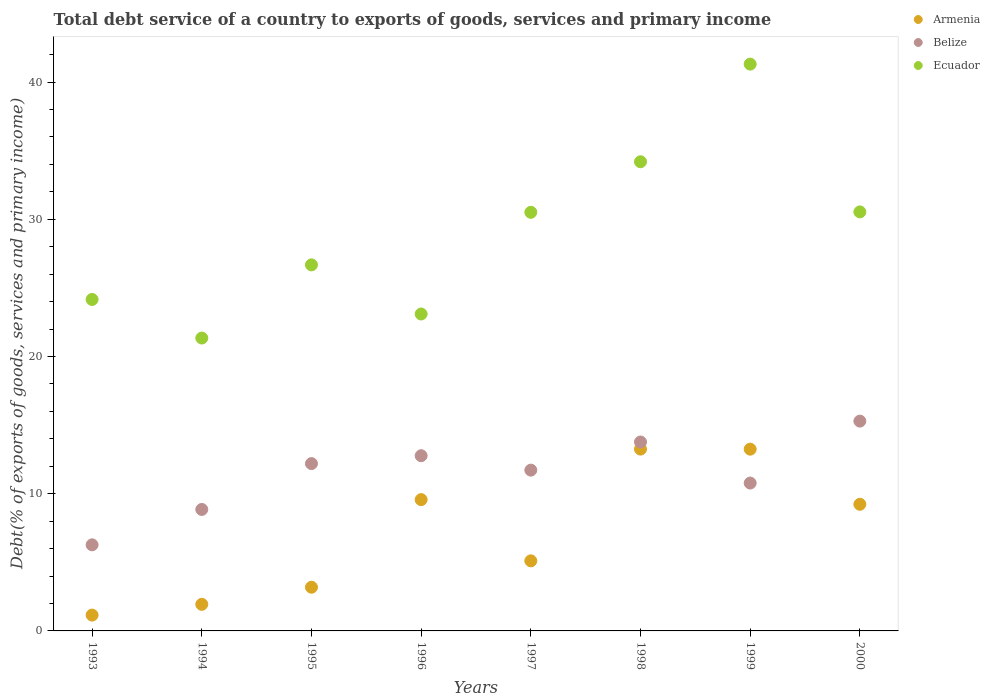How many different coloured dotlines are there?
Give a very brief answer. 3. Is the number of dotlines equal to the number of legend labels?
Provide a succinct answer. Yes. What is the total debt service in Ecuador in 2000?
Give a very brief answer. 30.54. Across all years, what is the maximum total debt service in Ecuador?
Offer a very short reply. 41.31. Across all years, what is the minimum total debt service in Armenia?
Your answer should be compact. 1.15. In which year was the total debt service in Ecuador maximum?
Your answer should be very brief. 1999. What is the total total debt service in Belize in the graph?
Give a very brief answer. 91.65. What is the difference between the total debt service in Ecuador in 1997 and that in 2000?
Make the answer very short. -0.03. What is the difference between the total debt service in Armenia in 1994 and the total debt service in Ecuador in 1996?
Offer a very short reply. -21.16. What is the average total debt service in Ecuador per year?
Make the answer very short. 28.98. In the year 2000, what is the difference between the total debt service in Ecuador and total debt service in Belize?
Ensure brevity in your answer.  15.25. In how many years, is the total debt service in Armenia greater than 4 %?
Give a very brief answer. 5. What is the ratio of the total debt service in Armenia in 1996 to that in 1998?
Your answer should be very brief. 0.72. Is the total debt service in Belize in 1995 less than that in 1997?
Keep it short and to the point. No. What is the difference between the highest and the second highest total debt service in Ecuador?
Offer a very short reply. 7.12. What is the difference between the highest and the lowest total debt service in Belize?
Your response must be concise. 9.02. In how many years, is the total debt service in Ecuador greater than the average total debt service in Ecuador taken over all years?
Make the answer very short. 4. Is the sum of the total debt service in Ecuador in 1999 and 2000 greater than the maximum total debt service in Armenia across all years?
Provide a short and direct response. Yes. Is it the case that in every year, the sum of the total debt service in Armenia and total debt service in Ecuador  is greater than the total debt service in Belize?
Your response must be concise. Yes. Is the total debt service in Armenia strictly greater than the total debt service in Ecuador over the years?
Make the answer very short. No. Is the total debt service in Armenia strictly less than the total debt service in Ecuador over the years?
Your answer should be compact. Yes. How many years are there in the graph?
Offer a terse response. 8. Are the values on the major ticks of Y-axis written in scientific E-notation?
Provide a succinct answer. No. Does the graph contain grids?
Offer a terse response. No. Where does the legend appear in the graph?
Keep it short and to the point. Top right. How many legend labels are there?
Offer a terse response. 3. How are the legend labels stacked?
Provide a succinct answer. Vertical. What is the title of the graph?
Provide a succinct answer. Total debt service of a country to exports of goods, services and primary income. What is the label or title of the Y-axis?
Your answer should be very brief. Debt(% of exports of goods, services and primary income). What is the Debt(% of exports of goods, services and primary income) in Armenia in 1993?
Provide a succinct answer. 1.15. What is the Debt(% of exports of goods, services and primary income) in Belize in 1993?
Your answer should be very brief. 6.28. What is the Debt(% of exports of goods, services and primary income) in Ecuador in 1993?
Keep it short and to the point. 24.16. What is the Debt(% of exports of goods, services and primary income) of Armenia in 1994?
Make the answer very short. 1.94. What is the Debt(% of exports of goods, services and primary income) in Belize in 1994?
Your answer should be very brief. 8.85. What is the Debt(% of exports of goods, services and primary income) in Ecuador in 1994?
Keep it short and to the point. 21.35. What is the Debt(% of exports of goods, services and primary income) of Armenia in 1995?
Keep it short and to the point. 3.18. What is the Debt(% of exports of goods, services and primary income) of Belize in 1995?
Make the answer very short. 12.19. What is the Debt(% of exports of goods, services and primary income) of Ecuador in 1995?
Your answer should be compact. 26.68. What is the Debt(% of exports of goods, services and primary income) in Armenia in 1996?
Your answer should be very brief. 9.57. What is the Debt(% of exports of goods, services and primary income) in Belize in 1996?
Your answer should be very brief. 12.77. What is the Debt(% of exports of goods, services and primary income) in Ecuador in 1996?
Keep it short and to the point. 23.1. What is the Debt(% of exports of goods, services and primary income) of Armenia in 1997?
Offer a very short reply. 5.11. What is the Debt(% of exports of goods, services and primary income) of Belize in 1997?
Give a very brief answer. 11.72. What is the Debt(% of exports of goods, services and primary income) in Ecuador in 1997?
Provide a succinct answer. 30.51. What is the Debt(% of exports of goods, services and primary income) of Armenia in 1998?
Keep it short and to the point. 13.25. What is the Debt(% of exports of goods, services and primary income) of Belize in 1998?
Provide a succinct answer. 13.77. What is the Debt(% of exports of goods, services and primary income) in Ecuador in 1998?
Your answer should be compact. 34.2. What is the Debt(% of exports of goods, services and primary income) of Armenia in 1999?
Your answer should be compact. 13.25. What is the Debt(% of exports of goods, services and primary income) of Belize in 1999?
Keep it short and to the point. 10.78. What is the Debt(% of exports of goods, services and primary income) of Ecuador in 1999?
Your answer should be compact. 41.31. What is the Debt(% of exports of goods, services and primary income) in Armenia in 2000?
Keep it short and to the point. 9.23. What is the Debt(% of exports of goods, services and primary income) in Belize in 2000?
Provide a short and direct response. 15.29. What is the Debt(% of exports of goods, services and primary income) in Ecuador in 2000?
Ensure brevity in your answer.  30.54. Across all years, what is the maximum Debt(% of exports of goods, services and primary income) in Armenia?
Provide a succinct answer. 13.25. Across all years, what is the maximum Debt(% of exports of goods, services and primary income) in Belize?
Your answer should be compact. 15.29. Across all years, what is the maximum Debt(% of exports of goods, services and primary income) in Ecuador?
Give a very brief answer. 41.31. Across all years, what is the minimum Debt(% of exports of goods, services and primary income) in Armenia?
Your answer should be very brief. 1.15. Across all years, what is the minimum Debt(% of exports of goods, services and primary income) in Belize?
Give a very brief answer. 6.28. Across all years, what is the minimum Debt(% of exports of goods, services and primary income) of Ecuador?
Make the answer very short. 21.35. What is the total Debt(% of exports of goods, services and primary income) of Armenia in the graph?
Your response must be concise. 56.68. What is the total Debt(% of exports of goods, services and primary income) of Belize in the graph?
Provide a succinct answer. 91.65. What is the total Debt(% of exports of goods, services and primary income) of Ecuador in the graph?
Provide a succinct answer. 231.84. What is the difference between the Debt(% of exports of goods, services and primary income) of Armenia in 1993 and that in 1994?
Make the answer very short. -0.79. What is the difference between the Debt(% of exports of goods, services and primary income) of Belize in 1993 and that in 1994?
Give a very brief answer. -2.58. What is the difference between the Debt(% of exports of goods, services and primary income) of Ecuador in 1993 and that in 1994?
Your answer should be very brief. 2.81. What is the difference between the Debt(% of exports of goods, services and primary income) of Armenia in 1993 and that in 1995?
Keep it short and to the point. -2.03. What is the difference between the Debt(% of exports of goods, services and primary income) of Belize in 1993 and that in 1995?
Offer a very short reply. -5.92. What is the difference between the Debt(% of exports of goods, services and primary income) of Ecuador in 1993 and that in 1995?
Give a very brief answer. -2.52. What is the difference between the Debt(% of exports of goods, services and primary income) in Armenia in 1993 and that in 1996?
Give a very brief answer. -8.42. What is the difference between the Debt(% of exports of goods, services and primary income) of Belize in 1993 and that in 1996?
Make the answer very short. -6.49. What is the difference between the Debt(% of exports of goods, services and primary income) in Ecuador in 1993 and that in 1996?
Your answer should be compact. 1.06. What is the difference between the Debt(% of exports of goods, services and primary income) of Armenia in 1993 and that in 1997?
Make the answer very short. -3.95. What is the difference between the Debt(% of exports of goods, services and primary income) of Belize in 1993 and that in 1997?
Your answer should be very brief. -5.44. What is the difference between the Debt(% of exports of goods, services and primary income) of Ecuador in 1993 and that in 1997?
Give a very brief answer. -6.35. What is the difference between the Debt(% of exports of goods, services and primary income) in Armenia in 1993 and that in 1998?
Provide a short and direct response. -12.1. What is the difference between the Debt(% of exports of goods, services and primary income) of Belize in 1993 and that in 1998?
Provide a succinct answer. -7.49. What is the difference between the Debt(% of exports of goods, services and primary income) of Ecuador in 1993 and that in 1998?
Ensure brevity in your answer.  -10.04. What is the difference between the Debt(% of exports of goods, services and primary income) of Armenia in 1993 and that in 1999?
Provide a succinct answer. -12.09. What is the difference between the Debt(% of exports of goods, services and primary income) in Belize in 1993 and that in 1999?
Provide a succinct answer. -4.5. What is the difference between the Debt(% of exports of goods, services and primary income) in Ecuador in 1993 and that in 1999?
Keep it short and to the point. -17.15. What is the difference between the Debt(% of exports of goods, services and primary income) in Armenia in 1993 and that in 2000?
Your answer should be very brief. -8.08. What is the difference between the Debt(% of exports of goods, services and primary income) of Belize in 1993 and that in 2000?
Offer a very short reply. -9.02. What is the difference between the Debt(% of exports of goods, services and primary income) in Ecuador in 1993 and that in 2000?
Provide a short and direct response. -6.38. What is the difference between the Debt(% of exports of goods, services and primary income) of Armenia in 1994 and that in 1995?
Offer a very short reply. -1.25. What is the difference between the Debt(% of exports of goods, services and primary income) of Belize in 1994 and that in 1995?
Offer a very short reply. -3.34. What is the difference between the Debt(% of exports of goods, services and primary income) of Ecuador in 1994 and that in 1995?
Provide a short and direct response. -5.33. What is the difference between the Debt(% of exports of goods, services and primary income) of Armenia in 1994 and that in 1996?
Your answer should be very brief. -7.63. What is the difference between the Debt(% of exports of goods, services and primary income) in Belize in 1994 and that in 1996?
Give a very brief answer. -3.92. What is the difference between the Debt(% of exports of goods, services and primary income) in Ecuador in 1994 and that in 1996?
Keep it short and to the point. -1.75. What is the difference between the Debt(% of exports of goods, services and primary income) in Armenia in 1994 and that in 1997?
Provide a succinct answer. -3.17. What is the difference between the Debt(% of exports of goods, services and primary income) in Belize in 1994 and that in 1997?
Give a very brief answer. -2.87. What is the difference between the Debt(% of exports of goods, services and primary income) of Ecuador in 1994 and that in 1997?
Provide a succinct answer. -9.16. What is the difference between the Debt(% of exports of goods, services and primary income) of Armenia in 1994 and that in 1998?
Provide a short and direct response. -11.31. What is the difference between the Debt(% of exports of goods, services and primary income) in Belize in 1994 and that in 1998?
Provide a succinct answer. -4.92. What is the difference between the Debt(% of exports of goods, services and primary income) of Ecuador in 1994 and that in 1998?
Your response must be concise. -12.85. What is the difference between the Debt(% of exports of goods, services and primary income) in Armenia in 1994 and that in 1999?
Make the answer very short. -11.31. What is the difference between the Debt(% of exports of goods, services and primary income) in Belize in 1994 and that in 1999?
Ensure brevity in your answer.  -1.92. What is the difference between the Debt(% of exports of goods, services and primary income) of Ecuador in 1994 and that in 1999?
Your response must be concise. -19.96. What is the difference between the Debt(% of exports of goods, services and primary income) in Armenia in 1994 and that in 2000?
Your answer should be very brief. -7.29. What is the difference between the Debt(% of exports of goods, services and primary income) in Belize in 1994 and that in 2000?
Offer a terse response. -6.44. What is the difference between the Debt(% of exports of goods, services and primary income) of Ecuador in 1994 and that in 2000?
Offer a terse response. -9.19. What is the difference between the Debt(% of exports of goods, services and primary income) of Armenia in 1995 and that in 1996?
Offer a terse response. -6.39. What is the difference between the Debt(% of exports of goods, services and primary income) in Belize in 1995 and that in 1996?
Provide a succinct answer. -0.58. What is the difference between the Debt(% of exports of goods, services and primary income) of Ecuador in 1995 and that in 1996?
Your response must be concise. 3.58. What is the difference between the Debt(% of exports of goods, services and primary income) in Armenia in 1995 and that in 1997?
Offer a terse response. -1.92. What is the difference between the Debt(% of exports of goods, services and primary income) of Belize in 1995 and that in 1997?
Offer a terse response. 0.48. What is the difference between the Debt(% of exports of goods, services and primary income) in Ecuador in 1995 and that in 1997?
Your response must be concise. -3.83. What is the difference between the Debt(% of exports of goods, services and primary income) of Armenia in 1995 and that in 1998?
Your response must be concise. -10.07. What is the difference between the Debt(% of exports of goods, services and primary income) in Belize in 1995 and that in 1998?
Offer a very short reply. -1.57. What is the difference between the Debt(% of exports of goods, services and primary income) in Ecuador in 1995 and that in 1998?
Ensure brevity in your answer.  -7.52. What is the difference between the Debt(% of exports of goods, services and primary income) in Armenia in 1995 and that in 1999?
Keep it short and to the point. -10.06. What is the difference between the Debt(% of exports of goods, services and primary income) of Belize in 1995 and that in 1999?
Offer a terse response. 1.42. What is the difference between the Debt(% of exports of goods, services and primary income) of Ecuador in 1995 and that in 1999?
Your answer should be very brief. -14.63. What is the difference between the Debt(% of exports of goods, services and primary income) of Armenia in 1995 and that in 2000?
Offer a very short reply. -6.05. What is the difference between the Debt(% of exports of goods, services and primary income) of Belize in 1995 and that in 2000?
Your answer should be very brief. -3.1. What is the difference between the Debt(% of exports of goods, services and primary income) of Ecuador in 1995 and that in 2000?
Keep it short and to the point. -3.86. What is the difference between the Debt(% of exports of goods, services and primary income) in Armenia in 1996 and that in 1997?
Make the answer very short. 4.46. What is the difference between the Debt(% of exports of goods, services and primary income) in Belize in 1996 and that in 1997?
Make the answer very short. 1.05. What is the difference between the Debt(% of exports of goods, services and primary income) of Ecuador in 1996 and that in 1997?
Your answer should be compact. -7.41. What is the difference between the Debt(% of exports of goods, services and primary income) of Armenia in 1996 and that in 1998?
Offer a very short reply. -3.68. What is the difference between the Debt(% of exports of goods, services and primary income) of Belize in 1996 and that in 1998?
Your answer should be very brief. -1. What is the difference between the Debt(% of exports of goods, services and primary income) in Ecuador in 1996 and that in 1998?
Your response must be concise. -11.1. What is the difference between the Debt(% of exports of goods, services and primary income) of Armenia in 1996 and that in 1999?
Provide a short and direct response. -3.68. What is the difference between the Debt(% of exports of goods, services and primary income) in Belize in 1996 and that in 1999?
Keep it short and to the point. 1.99. What is the difference between the Debt(% of exports of goods, services and primary income) of Ecuador in 1996 and that in 1999?
Your answer should be compact. -18.21. What is the difference between the Debt(% of exports of goods, services and primary income) in Armenia in 1996 and that in 2000?
Your answer should be very brief. 0.34. What is the difference between the Debt(% of exports of goods, services and primary income) in Belize in 1996 and that in 2000?
Your answer should be compact. -2.52. What is the difference between the Debt(% of exports of goods, services and primary income) in Ecuador in 1996 and that in 2000?
Provide a short and direct response. -7.44. What is the difference between the Debt(% of exports of goods, services and primary income) of Armenia in 1997 and that in 1998?
Ensure brevity in your answer.  -8.15. What is the difference between the Debt(% of exports of goods, services and primary income) of Belize in 1997 and that in 1998?
Ensure brevity in your answer.  -2.05. What is the difference between the Debt(% of exports of goods, services and primary income) of Ecuador in 1997 and that in 1998?
Make the answer very short. -3.68. What is the difference between the Debt(% of exports of goods, services and primary income) of Armenia in 1997 and that in 1999?
Your response must be concise. -8.14. What is the difference between the Debt(% of exports of goods, services and primary income) in Belize in 1997 and that in 1999?
Provide a succinct answer. 0.94. What is the difference between the Debt(% of exports of goods, services and primary income) of Armenia in 1997 and that in 2000?
Your response must be concise. -4.12. What is the difference between the Debt(% of exports of goods, services and primary income) of Belize in 1997 and that in 2000?
Keep it short and to the point. -3.57. What is the difference between the Debt(% of exports of goods, services and primary income) of Ecuador in 1997 and that in 2000?
Provide a short and direct response. -0.03. What is the difference between the Debt(% of exports of goods, services and primary income) in Armenia in 1998 and that in 1999?
Your response must be concise. 0.01. What is the difference between the Debt(% of exports of goods, services and primary income) of Belize in 1998 and that in 1999?
Offer a very short reply. 2.99. What is the difference between the Debt(% of exports of goods, services and primary income) in Ecuador in 1998 and that in 1999?
Offer a very short reply. -7.12. What is the difference between the Debt(% of exports of goods, services and primary income) of Armenia in 1998 and that in 2000?
Provide a short and direct response. 4.02. What is the difference between the Debt(% of exports of goods, services and primary income) of Belize in 1998 and that in 2000?
Your answer should be compact. -1.52. What is the difference between the Debt(% of exports of goods, services and primary income) in Ecuador in 1998 and that in 2000?
Offer a terse response. 3.65. What is the difference between the Debt(% of exports of goods, services and primary income) in Armenia in 1999 and that in 2000?
Offer a very short reply. 4.02. What is the difference between the Debt(% of exports of goods, services and primary income) in Belize in 1999 and that in 2000?
Offer a terse response. -4.51. What is the difference between the Debt(% of exports of goods, services and primary income) of Ecuador in 1999 and that in 2000?
Offer a terse response. 10.77. What is the difference between the Debt(% of exports of goods, services and primary income) in Armenia in 1993 and the Debt(% of exports of goods, services and primary income) in Belize in 1994?
Give a very brief answer. -7.7. What is the difference between the Debt(% of exports of goods, services and primary income) of Armenia in 1993 and the Debt(% of exports of goods, services and primary income) of Ecuador in 1994?
Ensure brevity in your answer.  -20.19. What is the difference between the Debt(% of exports of goods, services and primary income) of Belize in 1993 and the Debt(% of exports of goods, services and primary income) of Ecuador in 1994?
Ensure brevity in your answer.  -15.07. What is the difference between the Debt(% of exports of goods, services and primary income) of Armenia in 1993 and the Debt(% of exports of goods, services and primary income) of Belize in 1995?
Offer a terse response. -11.04. What is the difference between the Debt(% of exports of goods, services and primary income) of Armenia in 1993 and the Debt(% of exports of goods, services and primary income) of Ecuador in 1995?
Offer a very short reply. -25.53. What is the difference between the Debt(% of exports of goods, services and primary income) in Belize in 1993 and the Debt(% of exports of goods, services and primary income) in Ecuador in 1995?
Offer a terse response. -20.4. What is the difference between the Debt(% of exports of goods, services and primary income) in Armenia in 1993 and the Debt(% of exports of goods, services and primary income) in Belize in 1996?
Make the answer very short. -11.62. What is the difference between the Debt(% of exports of goods, services and primary income) in Armenia in 1993 and the Debt(% of exports of goods, services and primary income) in Ecuador in 1996?
Provide a short and direct response. -21.95. What is the difference between the Debt(% of exports of goods, services and primary income) of Belize in 1993 and the Debt(% of exports of goods, services and primary income) of Ecuador in 1996?
Your response must be concise. -16.82. What is the difference between the Debt(% of exports of goods, services and primary income) of Armenia in 1993 and the Debt(% of exports of goods, services and primary income) of Belize in 1997?
Your answer should be very brief. -10.57. What is the difference between the Debt(% of exports of goods, services and primary income) in Armenia in 1993 and the Debt(% of exports of goods, services and primary income) in Ecuador in 1997?
Provide a short and direct response. -29.36. What is the difference between the Debt(% of exports of goods, services and primary income) in Belize in 1993 and the Debt(% of exports of goods, services and primary income) in Ecuador in 1997?
Your answer should be very brief. -24.24. What is the difference between the Debt(% of exports of goods, services and primary income) of Armenia in 1993 and the Debt(% of exports of goods, services and primary income) of Belize in 1998?
Your answer should be compact. -12.62. What is the difference between the Debt(% of exports of goods, services and primary income) in Armenia in 1993 and the Debt(% of exports of goods, services and primary income) in Ecuador in 1998?
Ensure brevity in your answer.  -33.04. What is the difference between the Debt(% of exports of goods, services and primary income) of Belize in 1993 and the Debt(% of exports of goods, services and primary income) of Ecuador in 1998?
Provide a succinct answer. -27.92. What is the difference between the Debt(% of exports of goods, services and primary income) in Armenia in 1993 and the Debt(% of exports of goods, services and primary income) in Belize in 1999?
Offer a very short reply. -9.62. What is the difference between the Debt(% of exports of goods, services and primary income) of Armenia in 1993 and the Debt(% of exports of goods, services and primary income) of Ecuador in 1999?
Offer a very short reply. -40.16. What is the difference between the Debt(% of exports of goods, services and primary income) in Belize in 1993 and the Debt(% of exports of goods, services and primary income) in Ecuador in 1999?
Provide a short and direct response. -35.04. What is the difference between the Debt(% of exports of goods, services and primary income) in Armenia in 1993 and the Debt(% of exports of goods, services and primary income) in Belize in 2000?
Your answer should be compact. -14.14. What is the difference between the Debt(% of exports of goods, services and primary income) of Armenia in 1993 and the Debt(% of exports of goods, services and primary income) of Ecuador in 2000?
Give a very brief answer. -29.39. What is the difference between the Debt(% of exports of goods, services and primary income) of Belize in 1993 and the Debt(% of exports of goods, services and primary income) of Ecuador in 2000?
Make the answer very short. -24.27. What is the difference between the Debt(% of exports of goods, services and primary income) of Armenia in 1994 and the Debt(% of exports of goods, services and primary income) of Belize in 1995?
Your answer should be very brief. -10.26. What is the difference between the Debt(% of exports of goods, services and primary income) of Armenia in 1994 and the Debt(% of exports of goods, services and primary income) of Ecuador in 1995?
Offer a terse response. -24.74. What is the difference between the Debt(% of exports of goods, services and primary income) of Belize in 1994 and the Debt(% of exports of goods, services and primary income) of Ecuador in 1995?
Offer a very short reply. -17.83. What is the difference between the Debt(% of exports of goods, services and primary income) of Armenia in 1994 and the Debt(% of exports of goods, services and primary income) of Belize in 1996?
Provide a short and direct response. -10.83. What is the difference between the Debt(% of exports of goods, services and primary income) of Armenia in 1994 and the Debt(% of exports of goods, services and primary income) of Ecuador in 1996?
Give a very brief answer. -21.16. What is the difference between the Debt(% of exports of goods, services and primary income) in Belize in 1994 and the Debt(% of exports of goods, services and primary income) in Ecuador in 1996?
Provide a short and direct response. -14.25. What is the difference between the Debt(% of exports of goods, services and primary income) of Armenia in 1994 and the Debt(% of exports of goods, services and primary income) of Belize in 1997?
Offer a terse response. -9.78. What is the difference between the Debt(% of exports of goods, services and primary income) of Armenia in 1994 and the Debt(% of exports of goods, services and primary income) of Ecuador in 1997?
Your response must be concise. -28.57. What is the difference between the Debt(% of exports of goods, services and primary income) of Belize in 1994 and the Debt(% of exports of goods, services and primary income) of Ecuador in 1997?
Your answer should be very brief. -21.66. What is the difference between the Debt(% of exports of goods, services and primary income) in Armenia in 1994 and the Debt(% of exports of goods, services and primary income) in Belize in 1998?
Provide a short and direct response. -11.83. What is the difference between the Debt(% of exports of goods, services and primary income) of Armenia in 1994 and the Debt(% of exports of goods, services and primary income) of Ecuador in 1998?
Offer a terse response. -32.26. What is the difference between the Debt(% of exports of goods, services and primary income) of Belize in 1994 and the Debt(% of exports of goods, services and primary income) of Ecuador in 1998?
Ensure brevity in your answer.  -25.34. What is the difference between the Debt(% of exports of goods, services and primary income) in Armenia in 1994 and the Debt(% of exports of goods, services and primary income) in Belize in 1999?
Provide a short and direct response. -8.84. What is the difference between the Debt(% of exports of goods, services and primary income) of Armenia in 1994 and the Debt(% of exports of goods, services and primary income) of Ecuador in 1999?
Provide a succinct answer. -39.37. What is the difference between the Debt(% of exports of goods, services and primary income) of Belize in 1994 and the Debt(% of exports of goods, services and primary income) of Ecuador in 1999?
Provide a short and direct response. -32.46. What is the difference between the Debt(% of exports of goods, services and primary income) in Armenia in 1994 and the Debt(% of exports of goods, services and primary income) in Belize in 2000?
Offer a very short reply. -13.35. What is the difference between the Debt(% of exports of goods, services and primary income) in Armenia in 1994 and the Debt(% of exports of goods, services and primary income) in Ecuador in 2000?
Give a very brief answer. -28.6. What is the difference between the Debt(% of exports of goods, services and primary income) of Belize in 1994 and the Debt(% of exports of goods, services and primary income) of Ecuador in 2000?
Your answer should be very brief. -21.69. What is the difference between the Debt(% of exports of goods, services and primary income) of Armenia in 1995 and the Debt(% of exports of goods, services and primary income) of Belize in 1996?
Your response must be concise. -9.59. What is the difference between the Debt(% of exports of goods, services and primary income) in Armenia in 1995 and the Debt(% of exports of goods, services and primary income) in Ecuador in 1996?
Ensure brevity in your answer.  -19.91. What is the difference between the Debt(% of exports of goods, services and primary income) in Belize in 1995 and the Debt(% of exports of goods, services and primary income) in Ecuador in 1996?
Offer a very short reply. -10.9. What is the difference between the Debt(% of exports of goods, services and primary income) in Armenia in 1995 and the Debt(% of exports of goods, services and primary income) in Belize in 1997?
Offer a terse response. -8.54. What is the difference between the Debt(% of exports of goods, services and primary income) of Armenia in 1995 and the Debt(% of exports of goods, services and primary income) of Ecuador in 1997?
Provide a short and direct response. -27.33. What is the difference between the Debt(% of exports of goods, services and primary income) in Belize in 1995 and the Debt(% of exports of goods, services and primary income) in Ecuador in 1997?
Provide a short and direct response. -18.32. What is the difference between the Debt(% of exports of goods, services and primary income) of Armenia in 1995 and the Debt(% of exports of goods, services and primary income) of Belize in 1998?
Your answer should be very brief. -10.58. What is the difference between the Debt(% of exports of goods, services and primary income) in Armenia in 1995 and the Debt(% of exports of goods, services and primary income) in Ecuador in 1998?
Offer a very short reply. -31.01. What is the difference between the Debt(% of exports of goods, services and primary income) in Belize in 1995 and the Debt(% of exports of goods, services and primary income) in Ecuador in 1998?
Your answer should be compact. -22. What is the difference between the Debt(% of exports of goods, services and primary income) of Armenia in 1995 and the Debt(% of exports of goods, services and primary income) of Belize in 1999?
Offer a very short reply. -7.59. What is the difference between the Debt(% of exports of goods, services and primary income) of Armenia in 1995 and the Debt(% of exports of goods, services and primary income) of Ecuador in 1999?
Give a very brief answer. -38.13. What is the difference between the Debt(% of exports of goods, services and primary income) in Belize in 1995 and the Debt(% of exports of goods, services and primary income) in Ecuador in 1999?
Keep it short and to the point. -29.12. What is the difference between the Debt(% of exports of goods, services and primary income) in Armenia in 1995 and the Debt(% of exports of goods, services and primary income) in Belize in 2000?
Keep it short and to the point. -12.11. What is the difference between the Debt(% of exports of goods, services and primary income) in Armenia in 1995 and the Debt(% of exports of goods, services and primary income) in Ecuador in 2000?
Your answer should be very brief. -27.36. What is the difference between the Debt(% of exports of goods, services and primary income) in Belize in 1995 and the Debt(% of exports of goods, services and primary income) in Ecuador in 2000?
Make the answer very short. -18.35. What is the difference between the Debt(% of exports of goods, services and primary income) in Armenia in 1996 and the Debt(% of exports of goods, services and primary income) in Belize in 1997?
Provide a succinct answer. -2.15. What is the difference between the Debt(% of exports of goods, services and primary income) of Armenia in 1996 and the Debt(% of exports of goods, services and primary income) of Ecuador in 1997?
Offer a very short reply. -20.94. What is the difference between the Debt(% of exports of goods, services and primary income) in Belize in 1996 and the Debt(% of exports of goods, services and primary income) in Ecuador in 1997?
Offer a terse response. -17.74. What is the difference between the Debt(% of exports of goods, services and primary income) of Armenia in 1996 and the Debt(% of exports of goods, services and primary income) of Belize in 1998?
Offer a very short reply. -4.2. What is the difference between the Debt(% of exports of goods, services and primary income) in Armenia in 1996 and the Debt(% of exports of goods, services and primary income) in Ecuador in 1998?
Give a very brief answer. -24.63. What is the difference between the Debt(% of exports of goods, services and primary income) in Belize in 1996 and the Debt(% of exports of goods, services and primary income) in Ecuador in 1998?
Offer a very short reply. -21.43. What is the difference between the Debt(% of exports of goods, services and primary income) of Armenia in 1996 and the Debt(% of exports of goods, services and primary income) of Belize in 1999?
Your response must be concise. -1.21. What is the difference between the Debt(% of exports of goods, services and primary income) of Armenia in 1996 and the Debt(% of exports of goods, services and primary income) of Ecuador in 1999?
Your answer should be compact. -31.74. What is the difference between the Debt(% of exports of goods, services and primary income) of Belize in 1996 and the Debt(% of exports of goods, services and primary income) of Ecuador in 1999?
Provide a succinct answer. -28.54. What is the difference between the Debt(% of exports of goods, services and primary income) in Armenia in 1996 and the Debt(% of exports of goods, services and primary income) in Belize in 2000?
Make the answer very short. -5.72. What is the difference between the Debt(% of exports of goods, services and primary income) in Armenia in 1996 and the Debt(% of exports of goods, services and primary income) in Ecuador in 2000?
Offer a very short reply. -20.97. What is the difference between the Debt(% of exports of goods, services and primary income) of Belize in 1996 and the Debt(% of exports of goods, services and primary income) of Ecuador in 2000?
Ensure brevity in your answer.  -17.77. What is the difference between the Debt(% of exports of goods, services and primary income) in Armenia in 1997 and the Debt(% of exports of goods, services and primary income) in Belize in 1998?
Your response must be concise. -8.66. What is the difference between the Debt(% of exports of goods, services and primary income) in Armenia in 1997 and the Debt(% of exports of goods, services and primary income) in Ecuador in 1998?
Your answer should be compact. -29.09. What is the difference between the Debt(% of exports of goods, services and primary income) of Belize in 1997 and the Debt(% of exports of goods, services and primary income) of Ecuador in 1998?
Make the answer very short. -22.48. What is the difference between the Debt(% of exports of goods, services and primary income) of Armenia in 1997 and the Debt(% of exports of goods, services and primary income) of Belize in 1999?
Your answer should be compact. -5.67. What is the difference between the Debt(% of exports of goods, services and primary income) in Armenia in 1997 and the Debt(% of exports of goods, services and primary income) in Ecuador in 1999?
Offer a terse response. -36.2. What is the difference between the Debt(% of exports of goods, services and primary income) of Belize in 1997 and the Debt(% of exports of goods, services and primary income) of Ecuador in 1999?
Your answer should be very brief. -29.59. What is the difference between the Debt(% of exports of goods, services and primary income) in Armenia in 1997 and the Debt(% of exports of goods, services and primary income) in Belize in 2000?
Give a very brief answer. -10.18. What is the difference between the Debt(% of exports of goods, services and primary income) in Armenia in 1997 and the Debt(% of exports of goods, services and primary income) in Ecuador in 2000?
Your answer should be very brief. -25.43. What is the difference between the Debt(% of exports of goods, services and primary income) of Belize in 1997 and the Debt(% of exports of goods, services and primary income) of Ecuador in 2000?
Provide a succinct answer. -18.82. What is the difference between the Debt(% of exports of goods, services and primary income) in Armenia in 1998 and the Debt(% of exports of goods, services and primary income) in Belize in 1999?
Ensure brevity in your answer.  2.48. What is the difference between the Debt(% of exports of goods, services and primary income) of Armenia in 1998 and the Debt(% of exports of goods, services and primary income) of Ecuador in 1999?
Your response must be concise. -28.06. What is the difference between the Debt(% of exports of goods, services and primary income) in Belize in 1998 and the Debt(% of exports of goods, services and primary income) in Ecuador in 1999?
Make the answer very short. -27.54. What is the difference between the Debt(% of exports of goods, services and primary income) of Armenia in 1998 and the Debt(% of exports of goods, services and primary income) of Belize in 2000?
Your response must be concise. -2.04. What is the difference between the Debt(% of exports of goods, services and primary income) in Armenia in 1998 and the Debt(% of exports of goods, services and primary income) in Ecuador in 2000?
Provide a short and direct response. -17.29. What is the difference between the Debt(% of exports of goods, services and primary income) in Belize in 1998 and the Debt(% of exports of goods, services and primary income) in Ecuador in 2000?
Your response must be concise. -16.77. What is the difference between the Debt(% of exports of goods, services and primary income) of Armenia in 1999 and the Debt(% of exports of goods, services and primary income) of Belize in 2000?
Offer a very short reply. -2.04. What is the difference between the Debt(% of exports of goods, services and primary income) of Armenia in 1999 and the Debt(% of exports of goods, services and primary income) of Ecuador in 2000?
Make the answer very short. -17.29. What is the difference between the Debt(% of exports of goods, services and primary income) in Belize in 1999 and the Debt(% of exports of goods, services and primary income) in Ecuador in 2000?
Provide a short and direct response. -19.76. What is the average Debt(% of exports of goods, services and primary income) in Armenia per year?
Offer a very short reply. 7.09. What is the average Debt(% of exports of goods, services and primary income) in Belize per year?
Ensure brevity in your answer.  11.46. What is the average Debt(% of exports of goods, services and primary income) of Ecuador per year?
Give a very brief answer. 28.98. In the year 1993, what is the difference between the Debt(% of exports of goods, services and primary income) of Armenia and Debt(% of exports of goods, services and primary income) of Belize?
Keep it short and to the point. -5.12. In the year 1993, what is the difference between the Debt(% of exports of goods, services and primary income) of Armenia and Debt(% of exports of goods, services and primary income) of Ecuador?
Your answer should be very brief. -23.01. In the year 1993, what is the difference between the Debt(% of exports of goods, services and primary income) of Belize and Debt(% of exports of goods, services and primary income) of Ecuador?
Keep it short and to the point. -17.88. In the year 1994, what is the difference between the Debt(% of exports of goods, services and primary income) of Armenia and Debt(% of exports of goods, services and primary income) of Belize?
Make the answer very short. -6.91. In the year 1994, what is the difference between the Debt(% of exports of goods, services and primary income) of Armenia and Debt(% of exports of goods, services and primary income) of Ecuador?
Provide a succinct answer. -19.41. In the year 1994, what is the difference between the Debt(% of exports of goods, services and primary income) in Belize and Debt(% of exports of goods, services and primary income) in Ecuador?
Your answer should be compact. -12.49. In the year 1995, what is the difference between the Debt(% of exports of goods, services and primary income) in Armenia and Debt(% of exports of goods, services and primary income) in Belize?
Offer a very short reply. -9.01. In the year 1995, what is the difference between the Debt(% of exports of goods, services and primary income) in Armenia and Debt(% of exports of goods, services and primary income) in Ecuador?
Your answer should be compact. -23.5. In the year 1995, what is the difference between the Debt(% of exports of goods, services and primary income) in Belize and Debt(% of exports of goods, services and primary income) in Ecuador?
Provide a short and direct response. -14.49. In the year 1996, what is the difference between the Debt(% of exports of goods, services and primary income) of Armenia and Debt(% of exports of goods, services and primary income) of Ecuador?
Give a very brief answer. -13.53. In the year 1996, what is the difference between the Debt(% of exports of goods, services and primary income) in Belize and Debt(% of exports of goods, services and primary income) in Ecuador?
Provide a succinct answer. -10.33. In the year 1997, what is the difference between the Debt(% of exports of goods, services and primary income) of Armenia and Debt(% of exports of goods, services and primary income) of Belize?
Give a very brief answer. -6.61. In the year 1997, what is the difference between the Debt(% of exports of goods, services and primary income) in Armenia and Debt(% of exports of goods, services and primary income) in Ecuador?
Provide a succinct answer. -25.4. In the year 1997, what is the difference between the Debt(% of exports of goods, services and primary income) of Belize and Debt(% of exports of goods, services and primary income) of Ecuador?
Your answer should be very brief. -18.79. In the year 1998, what is the difference between the Debt(% of exports of goods, services and primary income) of Armenia and Debt(% of exports of goods, services and primary income) of Belize?
Offer a terse response. -0.52. In the year 1998, what is the difference between the Debt(% of exports of goods, services and primary income) of Armenia and Debt(% of exports of goods, services and primary income) of Ecuador?
Your answer should be very brief. -20.94. In the year 1998, what is the difference between the Debt(% of exports of goods, services and primary income) in Belize and Debt(% of exports of goods, services and primary income) in Ecuador?
Provide a succinct answer. -20.43. In the year 1999, what is the difference between the Debt(% of exports of goods, services and primary income) in Armenia and Debt(% of exports of goods, services and primary income) in Belize?
Give a very brief answer. 2.47. In the year 1999, what is the difference between the Debt(% of exports of goods, services and primary income) in Armenia and Debt(% of exports of goods, services and primary income) in Ecuador?
Ensure brevity in your answer.  -28.06. In the year 1999, what is the difference between the Debt(% of exports of goods, services and primary income) in Belize and Debt(% of exports of goods, services and primary income) in Ecuador?
Your answer should be compact. -30.53. In the year 2000, what is the difference between the Debt(% of exports of goods, services and primary income) in Armenia and Debt(% of exports of goods, services and primary income) in Belize?
Offer a very short reply. -6.06. In the year 2000, what is the difference between the Debt(% of exports of goods, services and primary income) of Armenia and Debt(% of exports of goods, services and primary income) of Ecuador?
Your response must be concise. -21.31. In the year 2000, what is the difference between the Debt(% of exports of goods, services and primary income) of Belize and Debt(% of exports of goods, services and primary income) of Ecuador?
Give a very brief answer. -15.25. What is the ratio of the Debt(% of exports of goods, services and primary income) in Armenia in 1993 to that in 1994?
Make the answer very short. 0.59. What is the ratio of the Debt(% of exports of goods, services and primary income) in Belize in 1993 to that in 1994?
Your response must be concise. 0.71. What is the ratio of the Debt(% of exports of goods, services and primary income) of Ecuador in 1993 to that in 1994?
Provide a succinct answer. 1.13. What is the ratio of the Debt(% of exports of goods, services and primary income) in Armenia in 1993 to that in 1995?
Provide a succinct answer. 0.36. What is the ratio of the Debt(% of exports of goods, services and primary income) in Belize in 1993 to that in 1995?
Provide a succinct answer. 0.51. What is the ratio of the Debt(% of exports of goods, services and primary income) of Ecuador in 1993 to that in 1995?
Offer a terse response. 0.91. What is the ratio of the Debt(% of exports of goods, services and primary income) in Armenia in 1993 to that in 1996?
Make the answer very short. 0.12. What is the ratio of the Debt(% of exports of goods, services and primary income) of Belize in 1993 to that in 1996?
Make the answer very short. 0.49. What is the ratio of the Debt(% of exports of goods, services and primary income) of Ecuador in 1993 to that in 1996?
Keep it short and to the point. 1.05. What is the ratio of the Debt(% of exports of goods, services and primary income) of Armenia in 1993 to that in 1997?
Keep it short and to the point. 0.23. What is the ratio of the Debt(% of exports of goods, services and primary income) in Belize in 1993 to that in 1997?
Offer a very short reply. 0.54. What is the ratio of the Debt(% of exports of goods, services and primary income) of Ecuador in 1993 to that in 1997?
Make the answer very short. 0.79. What is the ratio of the Debt(% of exports of goods, services and primary income) of Armenia in 1993 to that in 1998?
Offer a terse response. 0.09. What is the ratio of the Debt(% of exports of goods, services and primary income) of Belize in 1993 to that in 1998?
Provide a short and direct response. 0.46. What is the ratio of the Debt(% of exports of goods, services and primary income) of Ecuador in 1993 to that in 1998?
Provide a succinct answer. 0.71. What is the ratio of the Debt(% of exports of goods, services and primary income) of Armenia in 1993 to that in 1999?
Offer a terse response. 0.09. What is the ratio of the Debt(% of exports of goods, services and primary income) in Belize in 1993 to that in 1999?
Give a very brief answer. 0.58. What is the ratio of the Debt(% of exports of goods, services and primary income) of Ecuador in 1993 to that in 1999?
Ensure brevity in your answer.  0.58. What is the ratio of the Debt(% of exports of goods, services and primary income) of Belize in 1993 to that in 2000?
Make the answer very short. 0.41. What is the ratio of the Debt(% of exports of goods, services and primary income) of Ecuador in 1993 to that in 2000?
Provide a short and direct response. 0.79. What is the ratio of the Debt(% of exports of goods, services and primary income) in Armenia in 1994 to that in 1995?
Give a very brief answer. 0.61. What is the ratio of the Debt(% of exports of goods, services and primary income) in Belize in 1994 to that in 1995?
Make the answer very short. 0.73. What is the ratio of the Debt(% of exports of goods, services and primary income) of Ecuador in 1994 to that in 1995?
Keep it short and to the point. 0.8. What is the ratio of the Debt(% of exports of goods, services and primary income) of Armenia in 1994 to that in 1996?
Make the answer very short. 0.2. What is the ratio of the Debt(% of exports of goods, services and primary income) in Belize in 1994 to that in 1996?
Provide a succinct answer. 0.69. What is the ratio of the Debt(% of exports of goods, services and primary income) of Ecuador in 1994 to that in 1996?
Offer a very short reply. 0.92. What is the ratio of the Debt(% of exports of goods, services and primary income) in Armenia in 1994 to that in 1997?
Keep it short and to the point. 0.38. What is the ratio of the Debt(% of exports of goods, services and primary income) of Belize in 1994 to that in 1997?
Keep it short and to the point. 0.76. What is the ratio of the Debt(% of exports of goods, services and primary income) in Ecuador in 1994 to that in 1997?
Your answer should be very brief. 0.7. What is the ratio of the Debt(% of exports of goods, services and primary income) in Armenia in 1994 to that in 1998?
Provide a succinct answer. 0.15. What is the ratio of the Debt(% of exports of goods, services and primary income) in Belize in 1994 to that in 1998?
Provide a succinct answer. 0.64. What is the ratio of the Debt(% of exports of goods, services and primary income) of Ecuador in 1994 to that in 1998?
Ensure brevity in your answer.  0.62. What is the ratio of the Debt(% of exports of goods, services and primary income) in Armenia in 1994 to that in 1999?
Give a very brief answer. 0.15. What is the ratio of the Debt(% of exports of goods, services and primary income) in Belize in 1994 to that in 1999?
Provide a succinct answer. 0.82. What is the ratio of the Debt(% of exports of goods, services and primary income) in Ecuador in 1994 to that in 1999?
Your answer should be compact. 0.52. What is the ratio of the Debt(% of exports of goods, services and primary income) of Armenia in 1994 to that in 2000?
Offer a terse response. 0.21. What is the ratio of the Debt(% of exports of goods, services and primary income) of Belize in 1994 to that in 2000?
Provide a succinct answer. 0.58. What is the ratio of the Debt(% of exports of goods, services and primary income) of Ecuador in 1994 to that in 2000?
Your response must be concise. 0.7. What is the ratio of the Debt(% of exports of goods, services and primary income) in Armenia in 1995 to that in 1996?
Ensure brevity in your answer.  0.33. What is the ratio of the Debt(% of exports of goods, services and primary income) in Belize in 1995 to that in 1996?
Offer a terse response. 0.95. What is the ratio of the Debt(% of exports of goods, services and primary income) in Ecuador in 1995 to that in 1996?
Provide a succinct answer. 1.16. What is the ratio of the Debt(% of exports of goods, services and primary income) in Armenia in 1995 to that in 1997?
Make the answer very short. 0.62. What is the ratio of the Debt(% of exports of goods, services and primary income) of Belize in 1995 to that in 1997?
Provide a short and direct response. 1.04. What is the ratio of the Debt(% of exports of goods, services and primary income) in Ecuador in 1995 to that in 1997?
Your response must be concise. 0.87. What is the ratio of the Debt(% of exports of goods, services and primary income) in Armenia in 1995 to that in 1998?
Your answer should be very brief. 0.24. What is the ratio of the Debt(% of exports of goods, services and primary income) of Belize in 1995 to that in 1998?
Offer a terse response. 0.89. What is the ratio of the Debt(% of exports of goods, services and primary income) of Ecuador in 1995 to that in 1998?
Ensure brevity in your answer.  0.78. What is the ratio of the Debt(% of exports of goods, services and primary income) in Armenia in 1995 to that in 1999?
Ensure brevity in your answer.  0.24. What is the ratio of the Debt(% of exports of goods, services and primary income) in Belize in 1995 to that in 1999?
Offer a very short reply. 1.13. What is the ratio of the Debt(% of exports of goods, services and primary income) in Ecuador in 1995 to that in 1999?
Provide a short and direct response. 0.65. What is the ratio of the Debt(% of exports of goods, services and primary income) of Armenia in 1995 to that in 2000?
Your answer should be compact. 0.34. What is the ratio of the Debt(% of exports of goods, services and primary income) in Belize in 1995 to that in 2000?
Your response must be concise. 0.8. What is the ratio of the Debt(% of exports of goods, services and primary income) of Ecuador in 1995 to that in 2000?
Your answer should be compact. 0.87. What is the ratio of the Debt(% of exports of goods, services and primary income) of Armenia in 1996 to that in 1997?
Keep it short and to the point. 1.87. What is the ratio of the Debt(% of exports of goods, services and primary income) in Belize in 1996 to that in 1997?
Give a very brief answer. 1.09. What is the ratio of the Debt(% of exports of goods, services and primary income) in Ecuador in 1996 to that in 1997?
Keep it short and to the point. 0.76. What is the ratio of the Debt(% of exports of goods, services and primary income) of Armenia in 1996 to that in 1998?
Your answer should be very brief. 0.72. What is the ratio of the Debt(% of exports of goods, services and primary income) of Belize in 1996 to that in 1998?
Ensure brevity in your answer.  0.93. What is the ratio of the Debt(% of exports of goods, services and primary income) in Ecuador in 1996 to that in 1998?
Offer a very short reply. 0.68. What is the ratio of the Debt(% of exports of goods, services and primary income) in Armenia in 1996 to that in 1999?
Give a very brief answer. 0.72. What is the ratio of the Debt(% of exports of goods, services and primary income) in Belize in 1996 to that in 1999?
Provide a short and direct response. 1.18. What is the ratio of the Debt(% of exports of goods, services and primary income) in Ecuador in 1996 to that in 1999?
Make the answer very short. 0.56. What is the ratio of the Debt(% of exports of goods, services and primary income) in Armenia in 1996 to that in 2000?
Make the answer very short. 1.04. What is the ratio of the Debt(% of exports of goods, services and primary income) in Belize in 1996 to that in 2000?
Offer a terse response. 0.84. What is the ratio of the Debt(% of exports of goods, services and primary income) in Ecuador in 1996 to that in 2000?
Provide a short and direct response. 0.76. What is the ratio of the Debt(% of exports of goods, services and primary income) in Armenia in 1997 to that in 1998?
Give a very brief answer. 0.39. What is the ratio of the Debt(% of exports of goods, services and primary income) in Belize in 1997 to that in 1998?
Your answer should be very brief. 0.85. What is the ratio of the Debt(% of exports of goods, services and primary income) in Ecuador in 1997 to that in 1998?
Offer a terse response. 0.89. What is the ratio of the Debt(% of exports of goods, services and primary income) of Armenia in 1997 to that in 1999?
Give a very brief answer. 0.39. What is the ratio of the Debt(% of exports of goods, services and primary income) of Belize in 1997 to that in 1999?
Offer a terse response. 1.09. What is the ratio of the Debt(% of exports of goods, services and primary income) in Ecuador in 1997 to that in 1999?
Offer a very short reply. 0.74. What is the ratio of the Debt(% of exports of goods, services and primary income) in Armenia in 1997 to that in 2000?
Offer a terse response. 0.55. What is the ratio of the Debt(% of exports of goods, services and primary income) of Belize in 1997 to that in 2000?
Give a very brief answer. 0.77. What is the ratio of the Debt(% of exports of goods, services and primary income) of Ecuador in 1997 to that in 2000?
Offer a terse response. 1. What is the ratio of the Debt(% of exports of goods, services and primary income) in Armenia in 1998 to that in 1999?
Your response must be concise. 1. What is the ratio of the Debt(% of exports of goods, services and primary income) of Belize in 1998 to that in 1999?
Keep it short and to the point. 1.28. What is the ratio of the Debt(% of exports of goods, services and primary income) in Ecuador in 1998 to that in 1999?
Offer a very short reply. 0.83. What is the ratio of the Debt(% of exports of goods, services and primary income) of Armenia in 1998 to that in 2000?
Provide a succinct answer. 1.44. What is the ratio of the Debt(% of exports of goods, services and primary income) in Belize in 1998 to that in 2000?
Make the answer very short. 0.9. What is the ratio of the Debt(% of exports of goods, services and primary income) of Ecuador in 1998 to that in 2000?
Your answer should be very brief. 1.12. What is the ratio of the Debt(% of exports of goods, services and primary income) in Armenia in 1999 to that in 2000?
Your response must be concise. 1.44. What is the ratio of the Debt(% of exports of goods, services and primary income) in Belize in 1999 to that in 2000?
Your answer should be compact. 0.7. What is the ratio of the Debt(% of exports of goods, services and primary income) in Ecuador in 1999 to that in 2000?
Your answer should be very brief. 1.35. What is the difference between the highest and the second highest Debt(% of exports of goods, services and primary income) in Armenia?
Your answer should be very brief. 0.01. What is the difference between the highest and the second highest Debt(% of exports of goods, services and primary income) of Belize?
Provide a succinct answer. 1.52. What is the difference between the highest and the second highest Debt(% of exports of goods, services and primary income) of Ecuador?
Ensure brevity in your answer.  7.12. What is the difference between the highest and the lowest Debt(% of exports of goods, services and primary income) in Armenia?
Your answer should be compact. 12.1. What is the difference between the highest and the lowest Debt(% of exports of goods, services and primary income) in Belize?
Make the answer very short. 9.02. What is the difference between the highest and the lowest Debt(% of exports of goods, services and primary income) in Ecuador?
Offer a terse response. 19.96. 